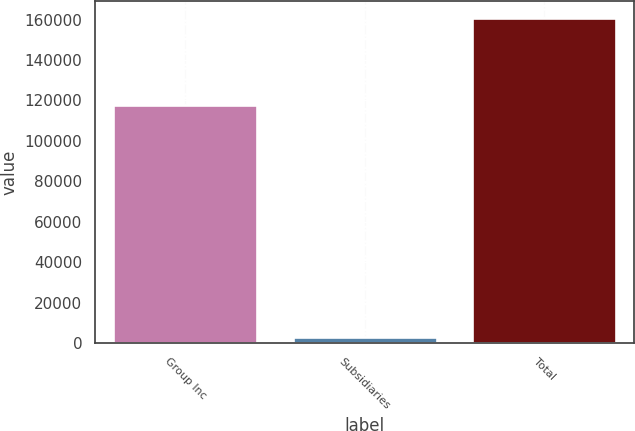Convert chart. <chart><loc_0><loc_0><loc_500><loc_500><bar_chart><fcel>Group Inc<fcel>Subsidiaries<fcel>Total<nl><fcel>117899<fcel>2967<fcel>160965<nl></chart> 